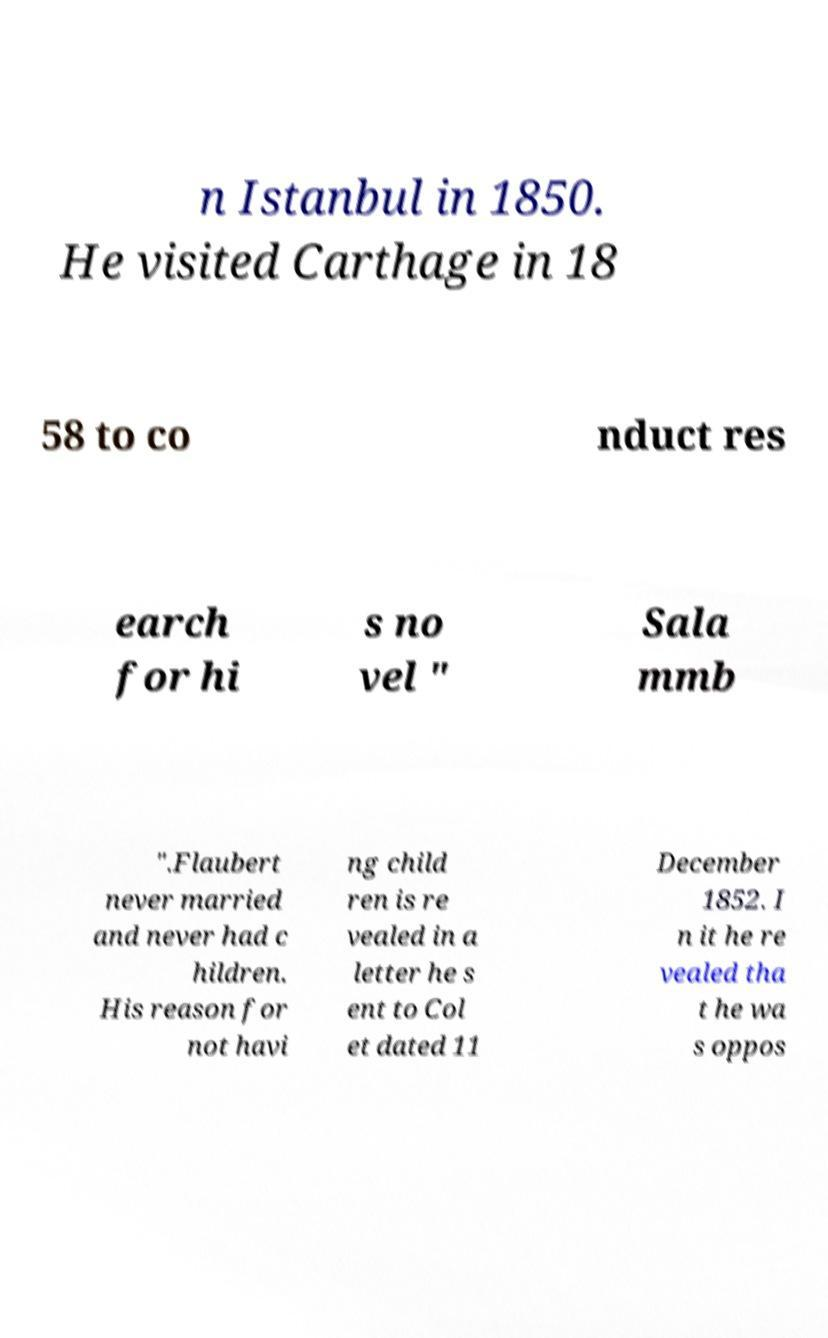What messages or text are displayed in this image? I need them in a readable, typed format. n Istanbul in 1850. He visited Carthage in 18 58 to co nduct res earch for hi s no vel " Sala mmb ".Flaubert never married and never had c hildren. His reason for not havi ng child ren is re vealed in a letter he s ent to Col et dated 11 December 1852. I n it he re vealed tha t he wa s oppos 